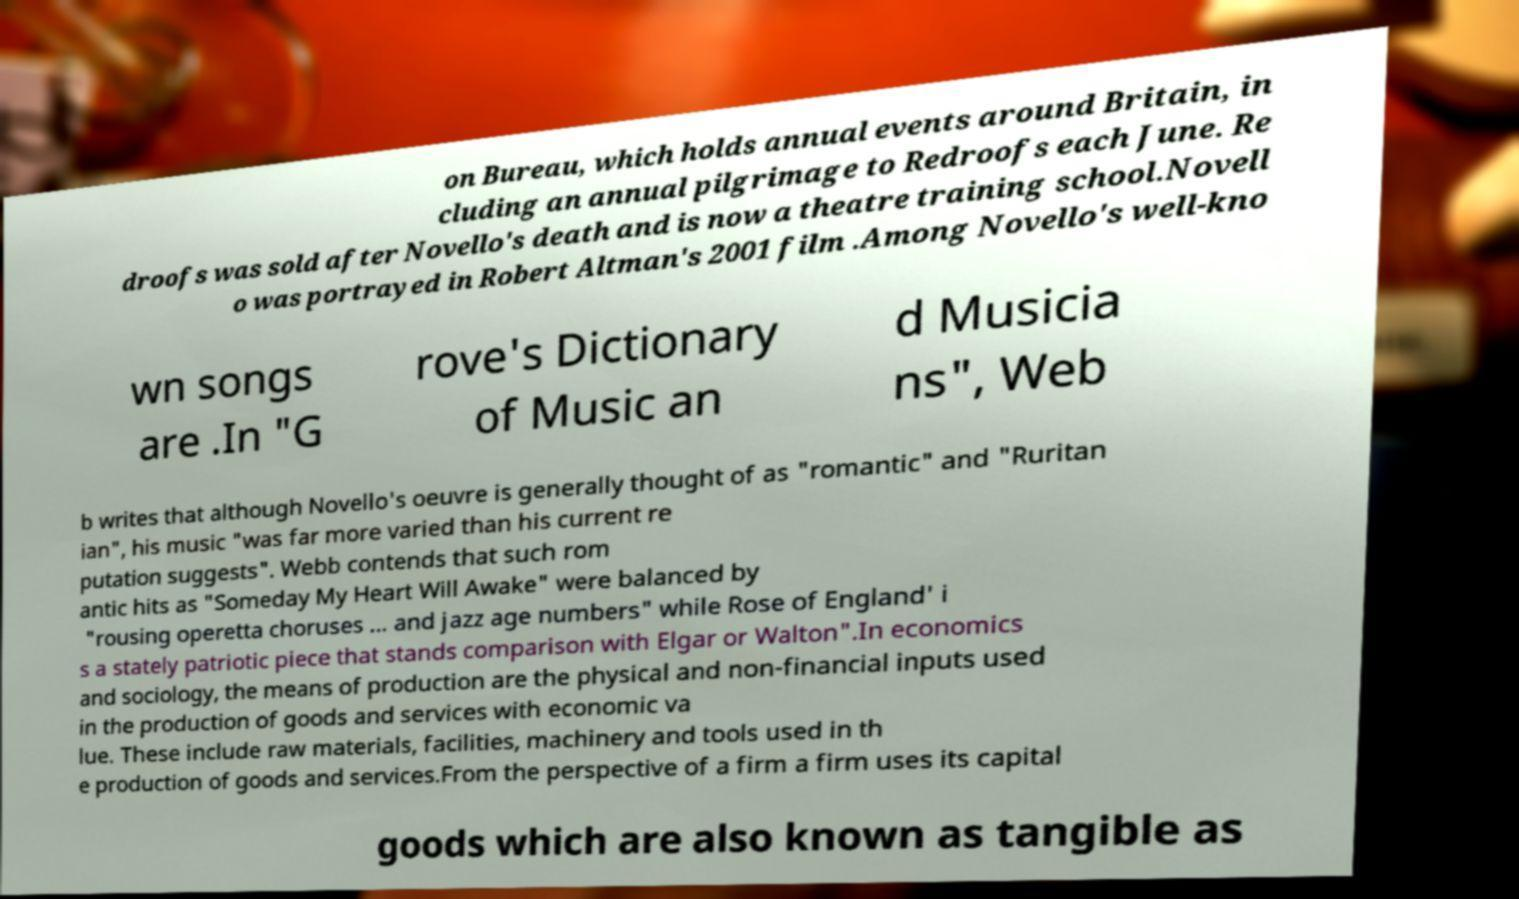Can you read and provide the text displayed in the image?This photo seems to have some interesting text. Can you extract and type it out for me? on Bureau, which holds annual events around Britain, in cluding an annual pilgrimage to Redroofs each June. Re droofs was sold after Novello's death and is now a theatre training school.Novell o was portrayed in Robert Altman's 2001 film .Among Novello's well-kno wn songs are .In "G rove's Dictionary of Music an d Musicia ns", Web b writes that although Novello's oeuvre is generally thought of as "romantic" and "Ruritan ian", his music "was far more varied than his current re putation suggests". Webb contends that such rom antic hits as "Someday My Heart Will Awake" were balanced by "rousing operetta choruses ... and jazz age numbers" while Rose of England' i s a stately patriotic piece that stands comparison with Elgar or Walton".In economics and sociology, the means of production are the physical and non-financial inputs used in the production of goods and services with economic va lue. These include raw materials, facilities, machinery and tools used in th e production of goods and services.From the perspective of a firm a firm uses its capital goods which are also known as tangible as 